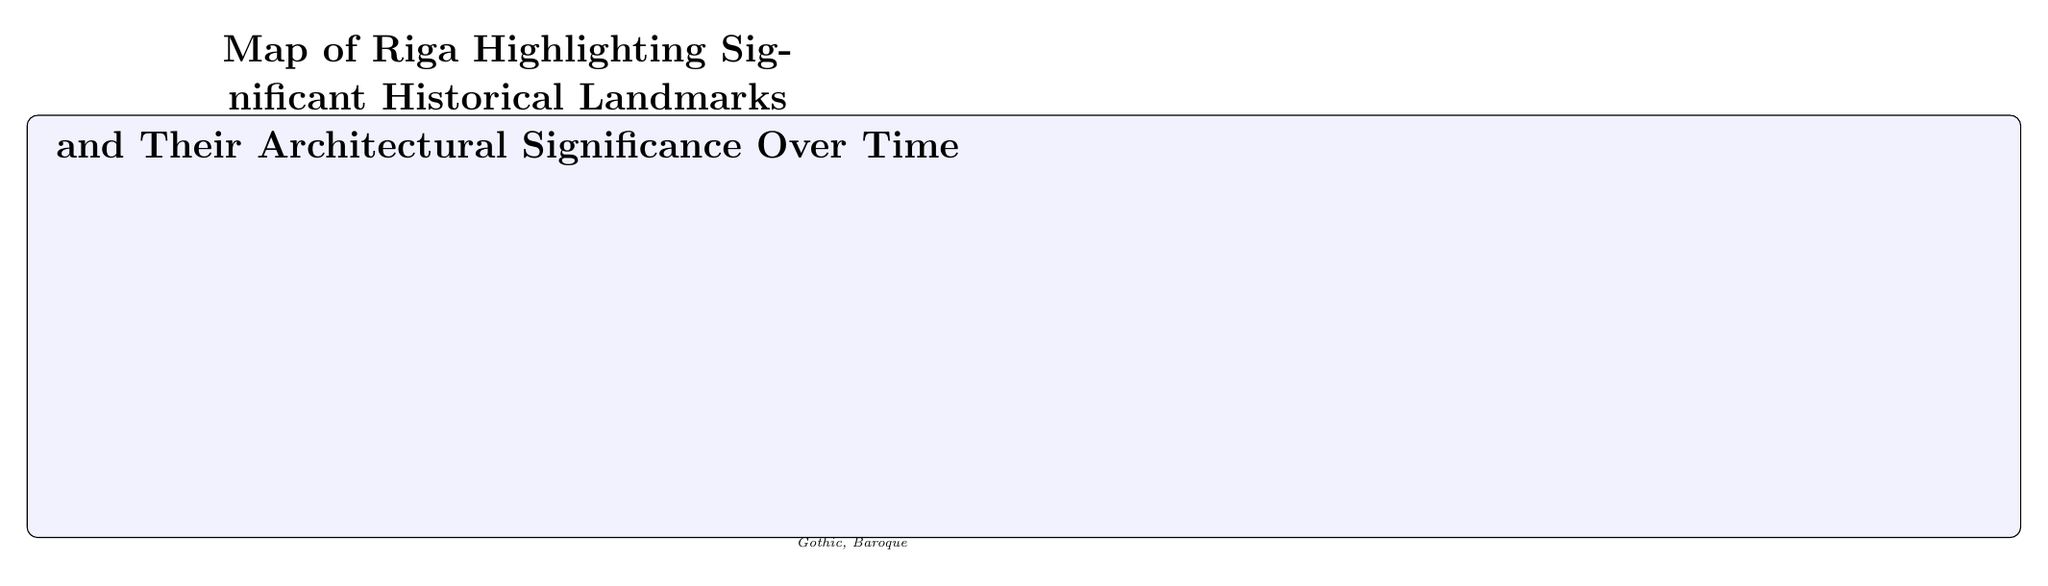What is a UNESCO World Heritage site in this map? The map highlights the "Old Town Riga" as a UNESCO World Heritage site, which is indicated directly beneath the landmark in the diagram.
Answer: Old Town Riga How many historical landmarks are directly connected to Old Town Riga? By counting the arrows connecting to the "Old Town Riga" node, there are six landmarks that connect directly to it: House of the Blackheads, St. Peter's Church, Riga Cathedral, Riga Castle, Freedom Monument, and the Art Nouveau District.
Answer: 6 Which landmark is associated with the 14th century and what style? The "House of the Blackheads" is directly linked to the 14th century in the diagram, specifically noted for its Dutch Renaissance style.
Answer: House of the Blackheads, Dutch Renaissance What architectural style is St. Peter's Church? The diagram identifies "St. Peter's Church" as being Gothic, as this information is provided in the description below the landmark node.
Answer: Gothic Which landmark was opened in 2014? The "National Library of Latvia" is marked in the diagram with the date of its opening in 2014, which is indicated in the description below the landmark node.
Answer: National Library of Latvia What is the relationship between the Freedom Monument and Old Town Riga? The Freedom Monument is indicated to be one of the landmarks connected directly to Old Town Riga by a connecting arrow, showing a direct relationship between them in the context of the map.
Answer: Direct connection What is unique about the Art Nouveau District noted on this map? The description under the "Art Nouveau District" highlights its rich decoration and eclectic forms, indicating what makes this area architecturally significant.
Answer: Rich decoration, eclectic forms What year was the Freedom Monument erected? The diagram states that the Freedom Monument was erected in the year 1935, which is provided as part of the description.
Answer: 1935 Which architectural styles are represented in the Riga Cathedral? The diagram states that the Riga Cathedral combines Romanesque, Gothic, and Baroque styles, as detailed in the description underneath the landmark.
Answer: Romanesque, Gothic, Baroque 